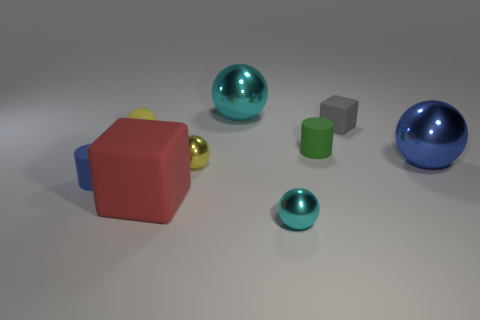Is the size of the gray cube the same as the yellow rubber object?
Your answer should be compact. Yes. How many things are either tiny purple metal balls or tiny objects that are behind the tiny cyan thing?
Keep it short and to the point. 5. What color is the large ball that is in front of the small yellow thing on the left side of the tiny yellow shiny ball?
Give a very brief answer. Blue. Is the color of the cube in front of the small green rubber thing the same as the small cube?
Your response must be concise. No. There is a small yellow sphere that is left of the tiny yellow metallic object; what is its material?
Your answer should be very brief. Rubber. What size is the blue cylinder?
Your answer should be compact. Small. Do the cyan ball behind the small yellow matte object and the red object have the same material?
Offer a very short reply. No. How many tiny cyan objects are there?
Your answer should be very brief. 1. What number of things are tiny spheres or cyan things?
Your answer should be very brief. 4. There is a cube that is in front of the big object to the right of the small cyan sphere; what number of small yellow spheres are on the right side of it?
Your answer should be very brief. 1. 